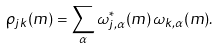Convert formula to latex. <formula><loc_0><loc_0><loc_500><loc_500>\rho _ { j k } ( m ) = \sum _ { \alpha } \omega _ { j , \alpha } ^ { \ast } ( m ) \, \omega _ { k , \alpha } ( m ) .</formula> 